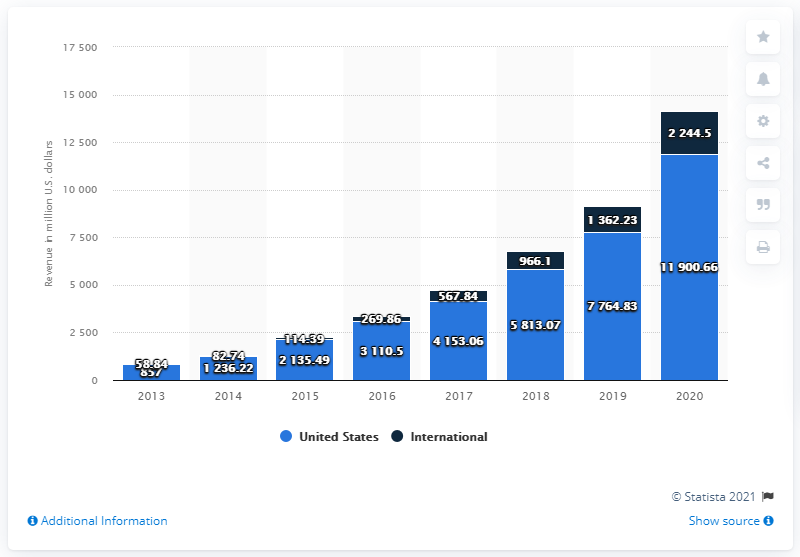List a handful of essential elements in this visual. In the year 2020, Wayfair generated a total revenue of approximately 11900.66 in the United States. 